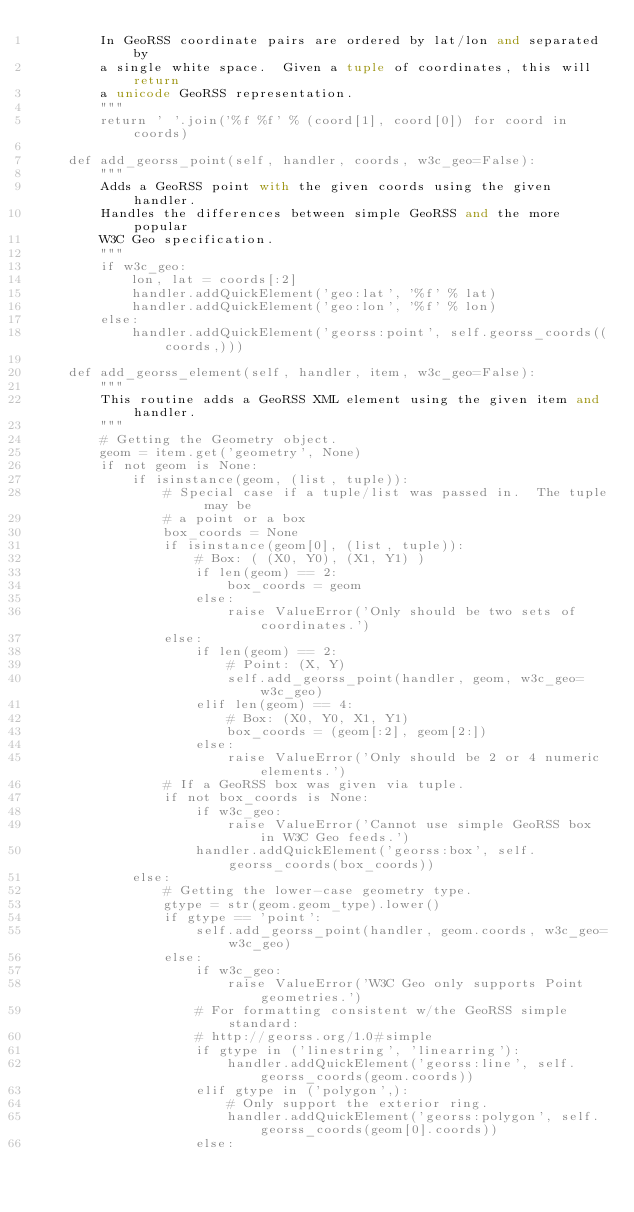Convert code to text. <code><loc_0><loc_0><loc_500><loc_500><_Python_>        In GeoRSS coordinate pairs are ordered by lat/lon and separated by
        a single white space.  Given a tuple of coordinates, this will return
        a unicode GeoRSS representation.
        """
        return ' '.join('%f %f' % (coord[1], coord[0]) for coord in coords)

    def add_georss_point(self, handler, coords, w3c_geo=False):
        """
        Adds a GeoRSS point with the given coords using the given handler.
        Handles the differences between simple GeoRSS and the more popular
        W3C Geo specification.
        """
        if w3c_geo:
            lon, lat = coords[:2]
            handler.addQuickElement('geo:lat', '%f' % lat)
            handler.addQuickElement('geo:lon', '%f' % lon)
        else:
            handler.addQuickElement('georss:point', self.georss_coords((coords,)))

    def add_georss_element(self, handler, item, w3c_geo=False):
        """
        This routine adds a GeoRSS XML element using the given item and handler.
        """
        # Getting the Geometry object.
        geom = item.get('geometry', None)
        if not geom is None:
            if isinstance(geom, (list, tuple)):
                # Special case if a tuple/list was passed in.  The tuple may be
                # a point or a box
                box_coords = None
                if isinstance(geom[0], (list, tuple)):
                    # Box: ( (X0, Y0), (X1, Y1) )
                    if len(geom) == 2:
                        box_coords = geom
                    else:
                        raise ValueError('Only should be two sets of coordinates.')
                else:
                    if len(geom) == 2:
                        # Point: (X, Y)
                        self.add_georss_point(handler, geom, w3c_geo=w3c_geo)
                    elif len(geom) == 4:
                        # Box: (X0, Y0, X1, Y1)
                        box_coords = (geom[:2], geom[2:])
                    else:
                        raise ValueError('Only should be 2 or 4 numeric elements.')
                # If a GeoRSS box was given via tuple.
                if not box_coords is None:
                    if w3c_geo:
                        raise ValueError('Cannot use simple GeoRSS box in W3C Geo feeds.')
                    handler.addQuickElement('georss:box', self.georss_coords(box_coords))
            else:
                # Getting the lower-case geometry type.
                gtype = str(geom.geom_type).lower()
                if gtype == 'point':
                    self.add_georss_point(handler, geom.coords, w3c_geo=w3c_geo)
                else:
                    if w3c_geo:
                        raise ValueError('W3C Geo only supports Point geometries.')
                    # For formatting consistent w/the GeoRSS simple standard:
                    # http://georss.org/1.0#simple
                    if gtype in ('linestring', 'linearring'):
                        handler.addQuickElement('georss:line', self.georss_coords(geom.coords))
                    elif gtype in ('polygon',):
                        # Only support the exterior ring.
                        handler.addQuickElement('georss:polygon', self.georss_coords(geom[0].coords))
                    else:</code> 